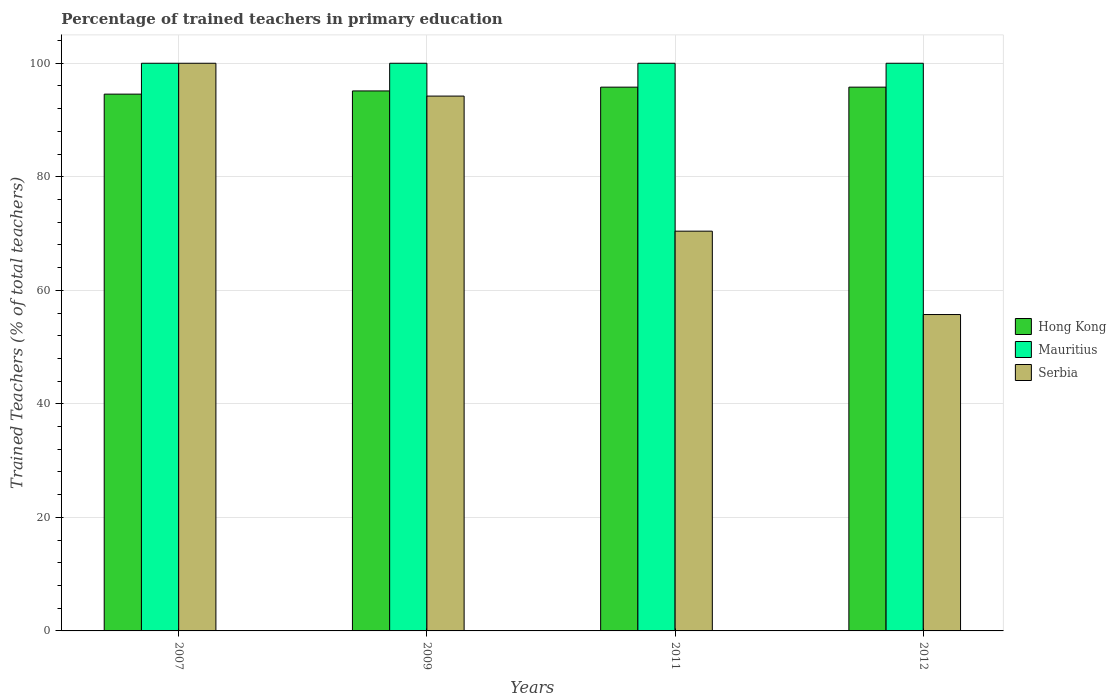How many different coloured bars are there?
Your answer should be very brief. 3. Are the number of bars on each tick of the X-axis equal?
Offer a very short reply. Yes. How many bars are there on the 1st tick from the left?
Offer a very short reply. 3. How many bars are there on the 3rd tick from the right?
Keep it short and to the point. 3. What is the percentage of trained teachers in Hong Kong in 2011?
Make the answer very short. 95.79. In which year was the percentage of trained teachers in Mauritius maximum?
Provide a succinct answer. 2007. In which year was the percentage of trained teachers in Hong Kong minimum?
Your answer should be compact. 2007. What is the total percentage of trained teachers in Serbia in the graph?
Provide a succinct answer. 320.37. What is the difference between the percentage of trained teachers in Hong Kong in 2009 and that in 2012?
Provide a succinct answer. -0.67. What is the difference between the percentage of trained teachers in Mauritius in 2007 and the percentage of trained teachers in Hong Kong in 2012?
Give a very brief answer. 4.21. What is the average percentage of trained teachers in Hong Kong per year?
Make the answer very short. 95.32. In the year 2012, what is the difference between the percentage of trained teachers in Mauritius and percentage of trained teachers in Serbia?
Offer a terse response. 44.27. What is the ratio of the percentage of trained teachers in Mauritius in 2009 to that in 2011?
Keep it short and to the point. 1. Is the difference between the percentage of trained teachers in Mauritius in 2011 and 2012 greater than the difference between the percentage of trained teachers in Serbia in 2011 and 2012?
Ensure brevity in your answer.  No. What is the difference between the highest and the second highest percentage of trained teachers in Hong Kong?
Offer a very short reply. 0. In how many years, is the percentage of trained teachers in Hong Kong greater than the average percentage of trained teachers in Hong Kong taken over all years?
Give a very brief answer. 2. Is the sum of the percentage of trained teachers in Serbia in 2011 and 2012 greater than the maximum percentage of trained teachers in Mauritius across all years?
Provide a short and direct response. Yes. What does the 3rd bar from the left in 2012 represents?
Your answer should be very brief. Serbia. What does the 1st bar from the right in 2011 represents?
Offer a very short reply. Serbia. Are all the bars in the graph horizontal?
Your answer should be very brief. No. How many legend labels are there?
Give a very brief answer. 3. How are the legend labels stacked?
Give a very brief answer. Vertical. What is the title of the graph?
Offer a very short reply. Percentage of trained teachers in primary education. Does "Zimbabwe" appear as one of the legend labels in the graph?
Give a very brief answer. No. What is the label or title of the X-axis?
Provide a short and direct response. Years. What is the label or title of the Y-axis?
Keep it short and to the point. Trained Teachers (% of total teachers). What is the Trained Teachers (% of total teachers) of Hong Kong in 2007?
Your answer should be very brief. 94.56. What is the Trained Teachers (% of total teachers) of Hong Kong in 2009?
Keep it short and to the point. 95.12. What is the Trained Teachers (% of total teachers) of Mauritius in 2009?
Provide a succinct answer. 100. What is the Trained Teachers (% of total teachers) of Serbia in 2009?
Give a very brief answer. 94.22. What is the Trained Teachers (% of total teachers) of Hong Kong in 2011?
Provide a short and direct response. 95.79. What is the Trained Teachers (% of total teachers) of Mauritius in 2011?
Your answer should be very brief. 100. What is the Trained Teachers (% of total teachers) of Serbia in 2011?
Make the answer very short. 70.42. What is the Trained Teachers (% of total teachers) of Hong Kong in 2012?
Provide a succinct answer. 95.79. What is the Trained Teachers (% of total teachers) in Serbia in 2012?
Your answer should be compact. 55.73. Across all years, what is the maximum Trained Teachers (% of total teachers) of Hong Kong?
Provide a short and direct response. 95.79. Across all years, what is the maximum Trained Teachers (% of total teachers) of Serbia?
Make the answer very short. 100. Across all years, what is the minimum Trained Teachers (% of total teachers) of Hong Kong?
Offer a very short reply. 94.56. Across all years, what is the minimum Trained Teachers (% of total teachers) in Serbia?
Make the answer very short. 55.73. What is the total Trained Teachers (% of total teachers) in Hong Kong in the graph?
Offer a very short reply. 381.27. What is the total Trained Teachers (% of total teachers) of Serbia in the graph?
Your response must be concise. 320.37. What is the difference between the Trained Teachers (% of total teachers) in Hong Kong in 2007 and that in 2009?
Your response must be concise. -0.56. What is the difference between the Trained Teachers (% of total teachers) of Serbia in 2007 and that in 2009?
Offer a very short reply. 5.78. What is the difference between the Trained Teachers (% of total teachers) in Hong Kong in 2007 and that in 2011?
Keep it short and to the point. -1.23. What is the difference between the Trained Teachers (% of total teachers) in Serbia in 2007 and that in 2011?
Make the answer very short. 29.58. What is the difference between the Trained Teachers (% of total teachers) in Hong Kong in 2007 and that in 2012?
Give a very brief answer. -1.23. What is the difference between the Trained Teachers (% of total teachers) in Mauritius in 2007 and that in 2012?
Offer a terse response. 0. What is the difference between the Trained Teachers (% of total teachers) in Serbia in 2007 and that in 2012?
Make the answer very short. 44.27. What is the difference between the Trained Teachers (% of total teachers) of Hong Kong in 2009 and that in 2011?
Offer a terse response. -0.67. What is the difference between the Trained Teachers (% of total teachers) of Mauritius in 2009 and that in 2011?
Provide a short and direct response. 0. What is the difference between the Trained Teachers (% of total teachers) of Serbia in 2009 and that in 2011?
Provide a succinct answer. 23.8. What is the difference between the Trained Teachers (% of total teachers) of Hong Kong in 2009 and that in 2012?
Keep it short and to the point. -0.67. What is the difference between the Trained Teachers (% of total teachers) of Mauritius in 2009 and that in 2012?
Provide a succinct answer. 0. What is the difference between the Trained Teachers (% of total teachers) in Serbia in 2009 and that in 2012?
Your answer should be very brief. 38.48. What is the difference between the Trained Teachers (% of total teachers) of Hong Kong in 2011 and that in 2012?
Keep it short and to the point. -0. What is the difference between the Trained Teachers (% of total teachers) of Mauritius in 2011 and that in 2012?
Offer a terse response. 0. What is the difference between the Trained Teachers (% of total teachers) in Serbia in 2011 and that in 2012?
Offer a terse response. 14.69. What is the difference between the Trained Teachers (% of total teachers) in Hong Kong in 2007 and the Trained Teachers (% of total teachers) in Mauritius in 2009?
Provide a succinct answer. -5.44. What is the difference between the Trained Teachers (% of total teachers) in Hong Kong in 2007 and the Trained Teachers (% of total teachers) in Serbia in 2009?
Offer a very short reply. 0.34. What is the difference between the Trained Teachers (% of total teachers) in Mauritius in 2007 and the Trained Teachers (% of total teachers) in Serbia in 2009?
Keep it short and to the point. 5.78. What is the difference between the Trained Teachers (% of total teachers) in Hong Kong in 2007 and the Trained Teachers (% of total teachers) in Mauritius in 2011?
Make the answer very short. -5.44. What is the difference between the Trained Teachers (% of total teachers) of Hong Kong in 2007 and the Trained Teachers (% of total teachers) of Serbia in 2011?
Give a very brief answer. 24.14. What is the difference between the Trained Teachers (% of total teachers) in Mauritius in 2007 and the Trained Teachers (% of total teachers) in Serbia in 2011?
Your response must be concise. 29.58. What is the difference between the Trained Teachers (% of total teachers) of Hong Kong in 2007 and the Trained Teachers (% of total teachers) of Mauritius in 2012?
Your answer should be very brief. -5.44. What is the difference between the Trained Teachers (% of total teachers) in Hong Kong in 2007 and the Trained Teachers (% of total teachers) in Serbia in 2012?
Your answer should be compact. 38.83. What is the difference between the Trained Teachers (% of total teachers) in Mauritius in 2007 and the Trained Teachers (% of total teachers) in Serbia in 2012?
Your response must be concise. 44.27. What is the difference between the Trained Teachers (% of total teachers) of Hong Kong in 2009 and the Trained Teachers (% of total teachers) of Mauritius in 2011?
Offer a terse response. -4.88. What is the difference between the Trained Teachers (% of total teachers) of Hong Kong in 2009 and the Trained Teachers (% of total teachers) of Serbia in 2011?
Keep it short and to the point. 24.7. What is the difference between the Trained Teachers (% of total teachers) of Mauritius in 2009 and the Trained Teachers (% of total teachers) of Serbia in 2011?
Provide a succinct answer. 29.58. What is the difference between the Trained Teachers (% of total teachers) in Hong Kong in 2009 and the Trained Teachers (% of total teachers) in Mauritius in 2012?
Offer a very short reply. -4.88. What is the difference between the Trained Teachers (% of total teachers) of Hong Kong in 2009 and the Trained Teachers (% of total teachers) of Serbia in 2012?
Your answer should be very brief. 39.39. What is the difference between the Trained Teachers (% of total teachers) in Mauritius in 2009 and the Trained Teachers (% of total teachers) in Serbia in 2012?
Offer a very short reply. 44.27. What is the difference between the Trained Teachers (% of total teachers) of Hong Kong in 2011 and the Trained Teachers (% of total teachers) of Mauritius in 2012?
Keep it short and to the point. -4.21. What is the difference between the Trained Teachers (% of total teachers) in Hong Kong in 2011 and the Trained Teachers (% of total teachers) in Serbia in 2012?
Keep it short and to the point. 40.06. What is the difference between the Trained Teachers (% of total teachers) of Mauritius in 2011 and the Trained Teachers (% of total teachers) of Serbia in 2012?
Give a very brief answer. 44.27. What is the average Trained Teachers (% of total teachers) of Hong Kong per year?
Your response must be concise. 95.32. What is the average Trained Teachers (% of total teachers) of Serbia per year?
Make the answer very short. 80.09. In the year 2007, what is the difference between the Trained Teachers (% of total teachers) in Hong Kong and Trained Teachers (% of total teachers) in Mauritius?
Keep it short and to the point. -5.44. In the year 2007, what is the difference between the Trained Teachers (% of total teachers) of Hong Kong and Trained Teachers (% of total teachers) of Serbia?
Make the answer very short. -5.44. In the year 2007, what is the difference between the Trained Teachers (% of total teachers) of Mauritius and Trained Teachers (% of total teachers) of Serbia?
Make the answer very short. 0. In the year 2009, what is the difference between the Trained Teachers (% of total teachers) of Hong Kong and Trained Teachers (% of total teachers) of Mauritius?
Make the answer very short. -4.88. In the year 2009, what is the difference between the Trained Teachers (% of total teachers) of Hong Kong and Trained Teachers (% of total teachers) of Serbia?
Your answer should be very brief. 0.91. In the year 2009, what is the difference between the Trained Teachers (% of total teachers) in Mauritius and Trained Teachers (% of total teachers) in Serbia?
Give a very brief answer. 5.78. In the year 2011, what is the difference between the Trained Teachers (% of total teachers) of Hong Kong and Trained Teachers (% of total teachers) of Mauritius?
Provide a succinct answer. -4.21. In the year 2011, what is the difference between the Trained Teachers (% of total teachers) of Hong Kong and Trained Teachers (% of total teachers) of Serbia?
Ensure brevity in your answer.  25.37. In the year 2011, what is the difference between the Trained Teachers (% of total teachers) in Mauritius and Trained Teachers (% of total teachers) in Serbia?
Give a very brief answer. 29.58. In the year 2012, what is the difference between the Trained Teachers (% of total teachers) of Hong Kong and Trained Teachers (% of total teachers) of Mauritius?
Keep it short and to the point. -4.21. In the year 2012, what is the difference between the Trained Teachers (% of total teachers) of Hong Kong and Trained Teachers (% of total teachers) of Serbia?
Provide a short and direct response. 40.06. In the year 2012, what is the difference between the Trained Teachers (% of total teachers) of Mauritius and Trained Teachers (% of total teachers) of Serbia?
Your response must be concise. 44.27. What is the ratio of the Trained Teachers (% of total teachers) of Serbia in 2007 to that in 2009?
Your response must be concise. 1.06. What is the ratio of the Trained Teachers (% of total teachers) in Hong Kong in 2007 to that in 2011?
Offer a very short reply. 0.99. What is the ratio of the Trained Teachers (% of total teachers) in Serbia in 2007 to that in 2011?
Your response must be concise. 1.42. What is the ratio of the Trained Teachers (% of total teachers) in Hong Kong in 2007 to that in 2012?
Offer a terse response. 0.99. What is the ratio of the Trained Teachers (% of total teachers) in Serbia in 2007 to that in 2012?
Offer a terse response. 1.79. What is the ratio of the Trained Teachers (% of total teachers) of Hong Kong in 2009 to that in 2011?
Your answer should be very brief. 0.99. What is the ratio of the Trained Teachers (% of total teachers) in Mauritius in 2009 to that in 2011?
Your answer should be very brief. 1. What is the ratio of the Trained Teachers (% of total teachers) of Serbia in 2009 to that in 2011?
Offer a terse response. 1.34. What is the ratio of the Trained Teachers (% of total teachers) of Mauritius in 2009 to that in 2012?
Your response must be concise. 1. What is the ratio of the Trained Teachers (% of total teachers) of Serbia in 2009 to that in 2012?
Make the answer very short. 1.69. What is the ratio of the Trained Teachers (% of total teachers) in Hong Kong in 2011 to that in 2012?
Offer a terse response. 1. What is the ratio of the Trained Teachers (% of total teachers) of Serbia in 2011 to that in 2012?
Ensure brevity in your answer.  1.26. What is the difference between the highest and the second highest Trained Teachers (% of total teachers) of Hong Kong?
Your answer should be compact. 0. What is the difference between the highest and the second highest Trained Teachers (% of total teachers) in Serbia?
Offer a very short reply. 5.78. What is the difference between the highest and the lowest Trained Teachers (% of total teachers) of Hong Kong?
Your answer should be compact. 1.23. What is the difference between the highest and the lowest Trained Teachers (% of total teachers) of Serbia?
Give a very brief answer. 44.27. 